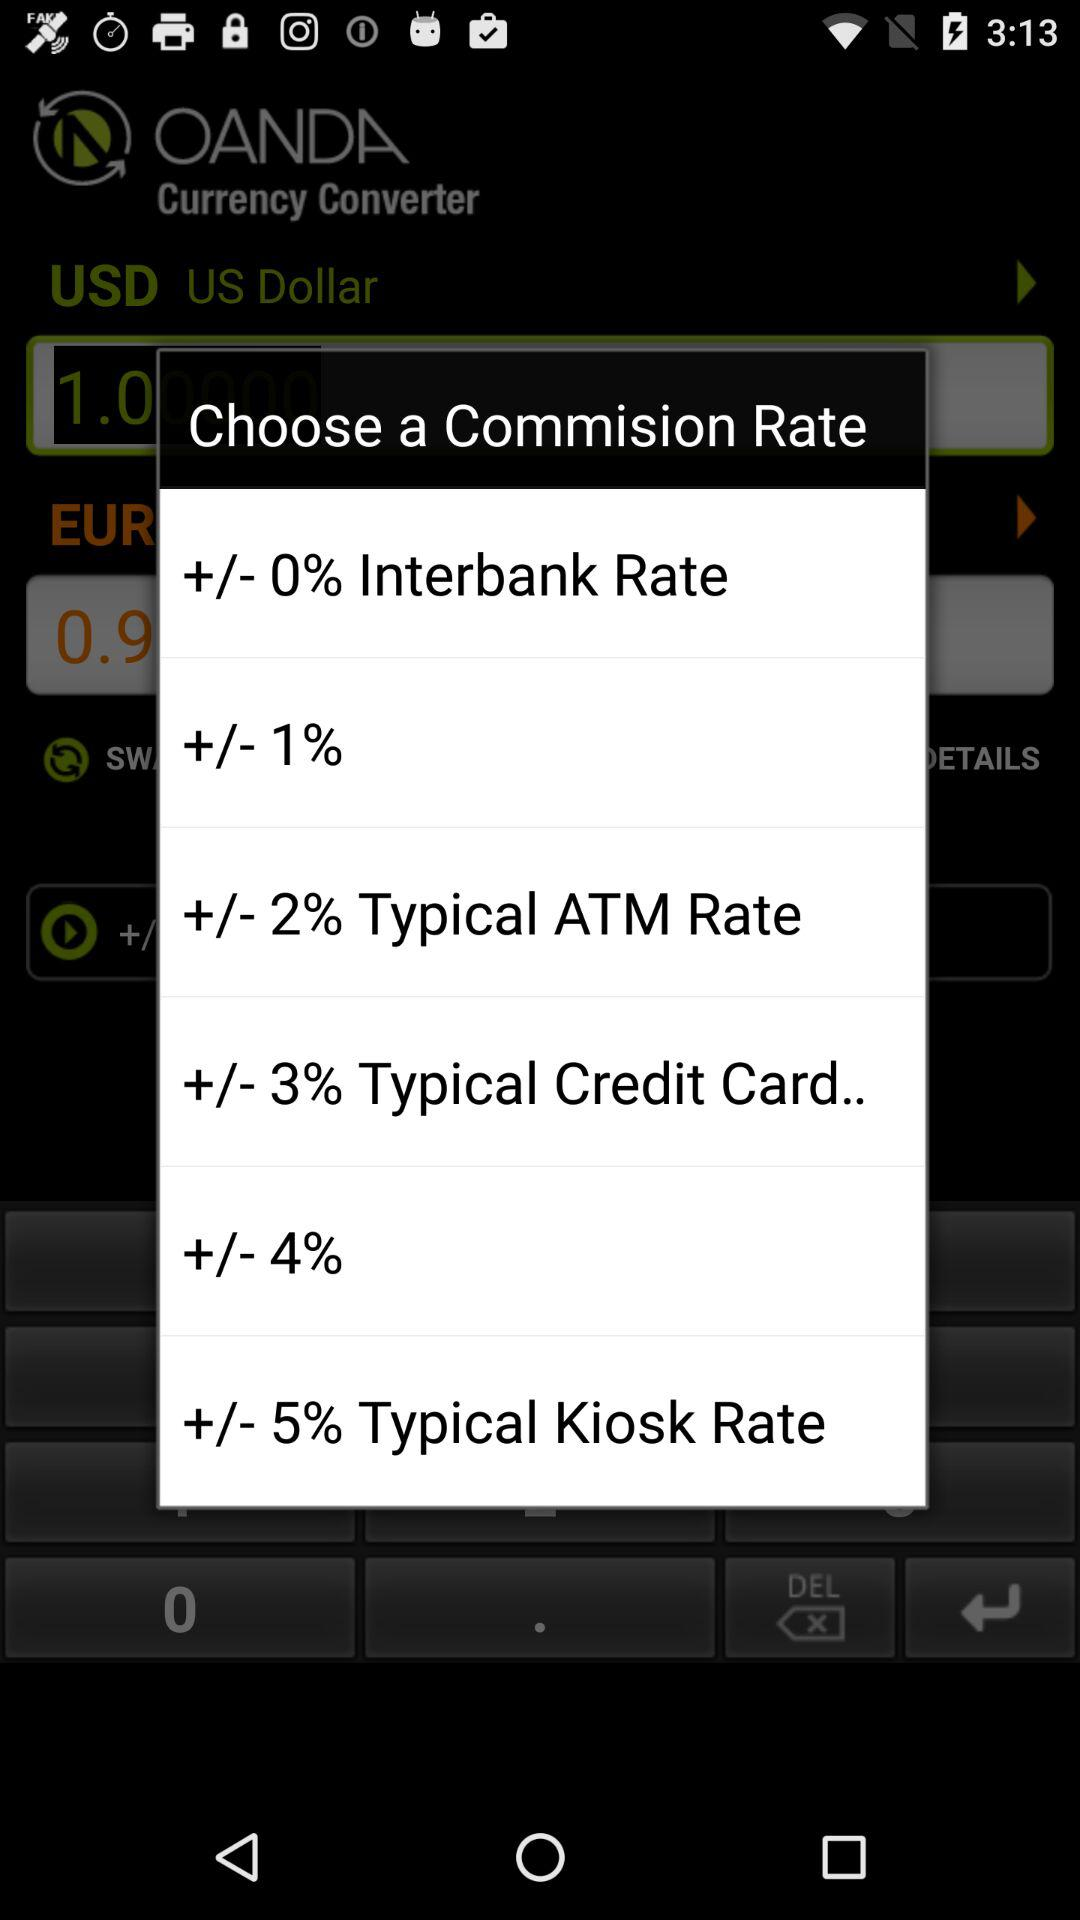What is the difference in percentage points between the Typical ATM Rate and the +/- 0% Interbank Rate?
Answer the question using a single word or phrase. 2 